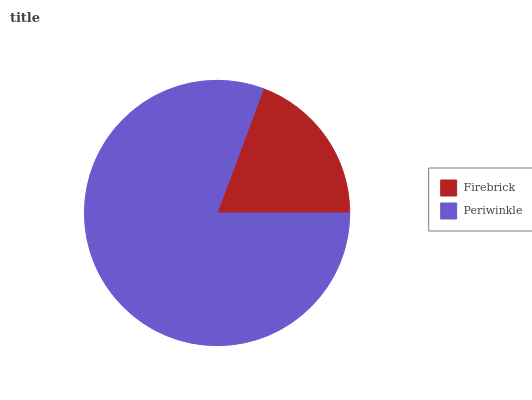Is Firebrick the minimum?
Answer yes or no. Yes. Is Periwinkle the maximum?
Answer yes or no. Yes. Is Periwinkle the minimum?
Answer yes or no. No. Is Periwinkle greater than Firebrick?
Answer yes or no. Yes. Is Firebrick less than Periwinkle?
Answer yes or no. Yes. Is Firebrick greater than Periwinkle?
Answer yes or no. No. Is Periwinkle less than Firebrick?
Answer yes or no. No. Is Periwinkle the high median?
Answer yes or no. Yes. Is Firebrick the low median?
Answer yes or no. Yes. Is Firebrick the high median?
Answer yes or no. No. Is Periwinkle the low median?
Answer yes or no. No. 